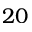<formula> <loc_0><loc_0><loc_500><loc_500>2 0</formula> 